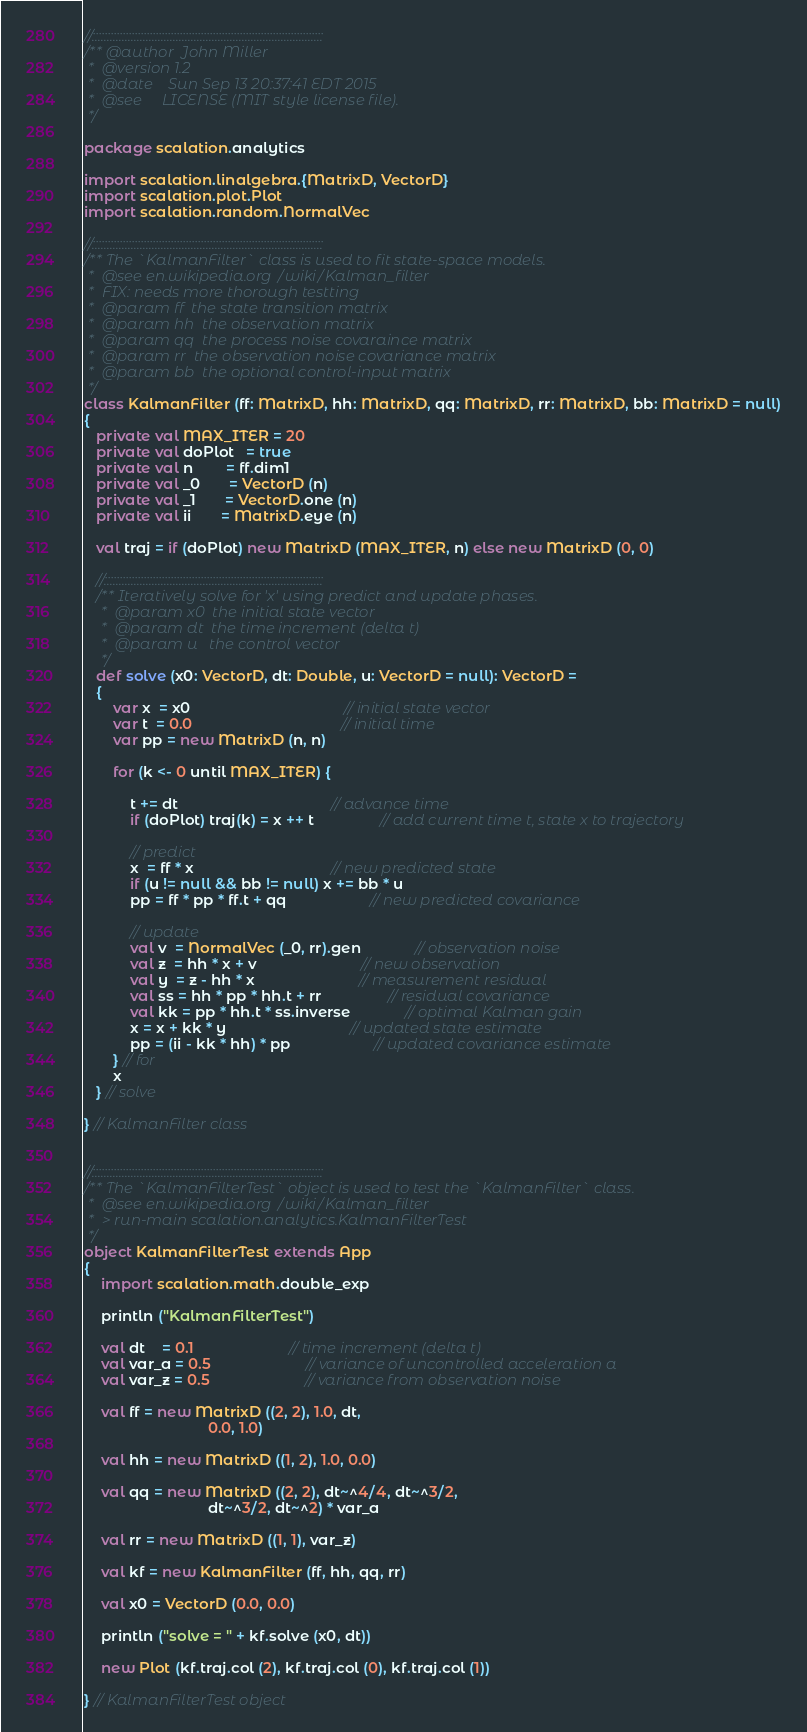Convert code to text. <code><loc_0><loc_0><loc_500><loc_500><_Scala_>
//:::::::::::::::::::::::::::::::::::::::::::::::::::::::::::::::::::::::::::::
/** @author  John Miller
 *  @version 1.2
 *  @date    Sun Sep 13 20:37:41 EDT 2015
 *  @see     LICENSE (MIT style license file).
 */

package scalation.analytics

import scalation.linalgebra.{MatrixD, VectorD}
import scalation.plot.Plot
import scalation.random.NormalVec

//:::::::::::::::::::::::::::::::::::::::::::::::::::::::::::::::::::::::::::::
/** The `KalmanFilter` class is used to fit state-space models.
 *  @see en.wikipedia.org/wiki/Kalman_filter
 *  FIX: needs more thorough testting
 *  @param ff  the state transition matrix
 *  @param hh  the observation matrix
 *  @param qq  the process noise covaraince matrix
 *  @param rr  the observation noise covariance matrix
 *  @param bb  the optional control-input matrix
 */
class KalmanFilter (ff: MatrixD, hh: MatrixD, qq: MatrixD, rr: MatrixD, bb: MatrixD = null)
{
   private val MAX_ITER = 20
   private val doPlot   = true
   private val n        = ff.dim1
   private val _0       = VectorD (n)
   private val _1       = VectorD.one (n)
   private val ii       = MatrixD.eye (n)

   val traj = if (doPlot) new MatrixD (MAX_ITER, n) else new MatrixD (0, 0)

   //:::::::::::::::::::::::::::::::::::::::::::::::::::::::::::::::::::::::::
   /** Iteratively solve for 'x' using predict and update phases.
    *  @param x0  the initial state vector
    *  @param dt  the time increment (delta t)
    *  @param u   the control vector
    */
   def solve (x0: VectorD, dt: Double, u: VectorD = null): VectorD =
   {
       var x  = x0                                     // initial state vector
       var t  = 0.0                                    // initial time
       var pp = new MatrixD (n, n)

       for (k <- 0 until MAX_ITER) {

           t += dt                                     // advance time
           if (doPlot) traj(k) = x ++ t                // add current time t, state x to trajectory

           // predict
           x  = ff * x                                 // new predicted state
           if (u != null && bb != null) x += bb * u
           pp = ff * pp * ff.t + qq                    // new predicted covariance

           // update
           val v  = NormalVec (_0, rr).gen             // observation noise
           val z  = hh * x + v                         // new observation
           val y  = z - hh * x                         // measurement residual
           val ss = hh * pp * hh.t + rr                // residual covariance
           val kk = pp * hh.t * ss.inverse             // optimal Kalman gain
           x = x + kk * y                              // updated state estimate
           pp = (ii - kk * hh) * pp                    // updated covariance estimate
       } // for
       x
   } // solve

} // KalmanFilter class


//:::::::::::::::::::::::::::::::::::::::::::::::::::::::::::::::::::::::::::::
/** The `KalmanFilterTest` object is used to test the `KalmanFilter` class.
 *  @see en.wikipedia.org/wiki/Kalman_filter
 *  > run-main scalation.analytics.KalmanFilterTest
 */
object KalmanFilterTest extends App
{
    import scalation.math.double_exp

    println ("KalmanFilterTest")

    val dt    = 0.1                       // time increment (delta t)
    val var_a = 0.5                       // variance of uncontrolled acceleration a
    val var_z = 0.5                       // variance from observation noise

    val ff = new MatrixD ((2, 2), 1.0, dt,
                              0.0, 1.0)

    val hh = new MatrixD ((1, 2), 1.0, 0.0)

    val qq = new MatrixD ((2, 2), dt~^4/4, dt~^3/2,
                              dt~^3/2, dt~^2) * var_a

    val rr = new MatrixD ((1, 1), var_z)

    val kf = new KalmanFilter (ff, hh, qq, rr)

    val x0 = VectorD (0.0, 0.0)

    println ("solve = " + kf.solve (x0, dt))

    new Plot (kf.traj.col (2), kf.traj.col (0), kf.traj.col (1))

} // KalmanFilterTest object

</code> 